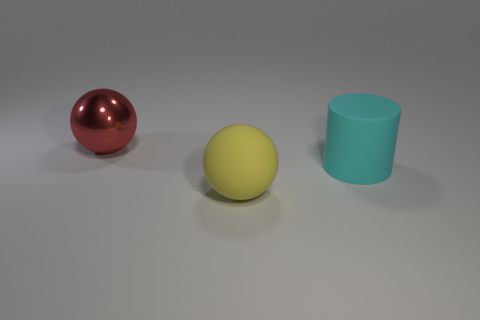Add 3 small purple matte objects. How many objects exist? 6 Add 3 blue metallic things. How many blue metallic things exist? 3 Subtract 1 cyan cylinders. How many objects are left? 2 Subtract all cylinders. How many objects are left? 2 Subtract all small yellow rubber objects. Subtract all large red balls. How many objects are left? 2 Add 3 cylinders. How many cylinders are left? 4 